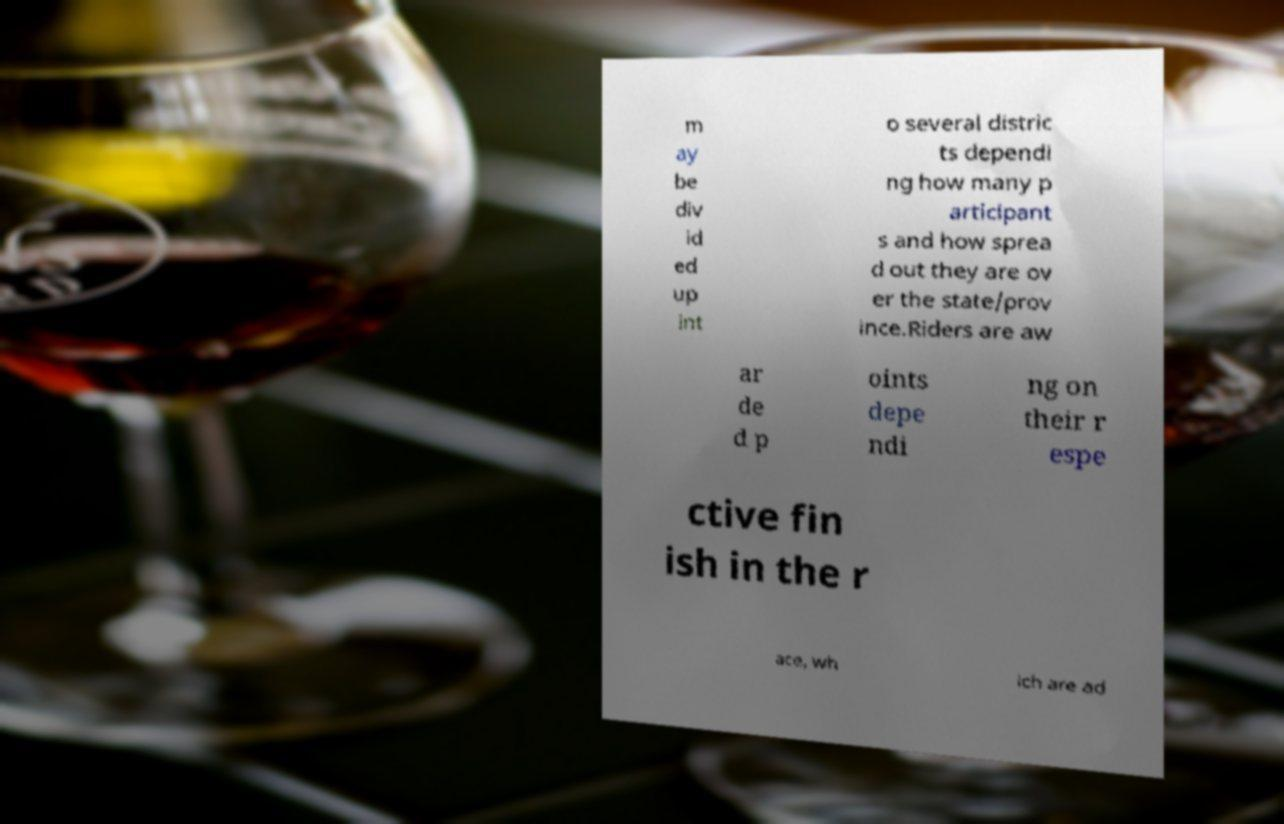Could you assist in decoding the text presented in this image and type it out clearly? m ay be div id ed up int o several distric ts dependi ng how many p articipant s and how sprea d out they are ov er the state/prov ince.Riders are aw ar de d p oints depe ndi ng on their r espe ctive fin ish in the r ace, wh ich are ad 